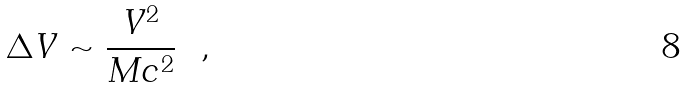<formula> <loc_0><loc_0><loc_500><loc_500>\Delta V \sim \frac { V ^ { 2 } } { M c ^ { 2 } } \ \ ,</formula> 